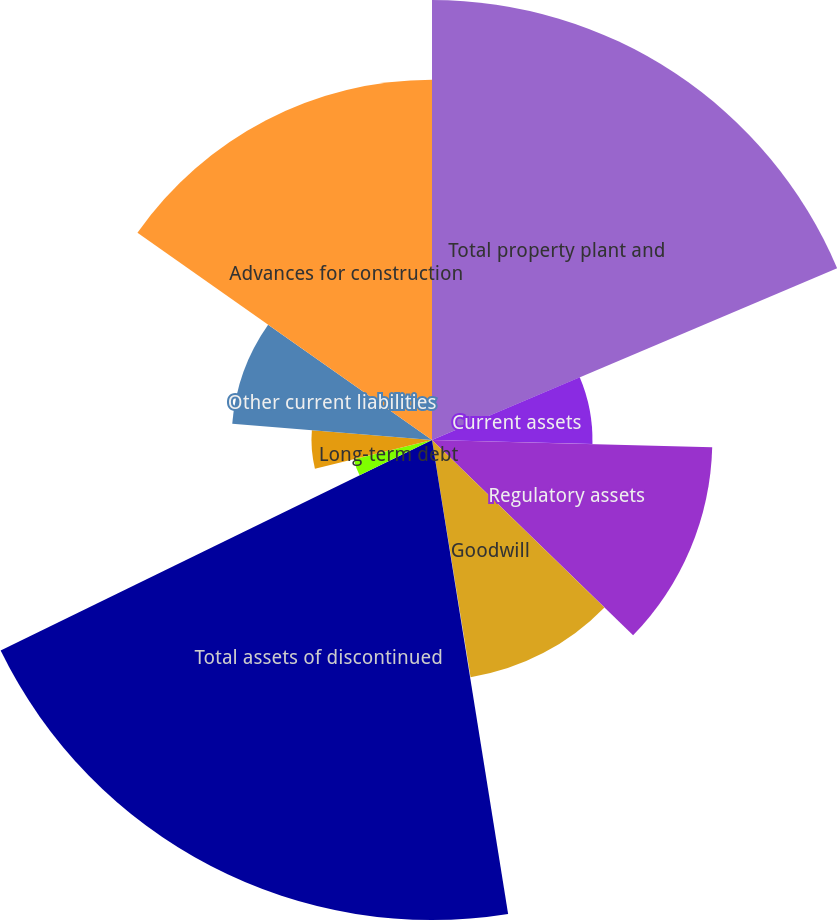Convert chart to OTSL. <chart><loc_0><loc_0><loc_500><loc_500><pie_chart><fcel>Total property plant and<fcel>Current assets<fcel>Regulatory assets<fcel>Goodwill<fcel>Other<fcel>Total assets of discontinued<fcel>Long-term debt<fcel>Current portion of long-term<fcel>Other current liabilities<fcel>Advances for construction<nl><fcel>18.62%<fcel>6.79%<fcel>11.86%<fcel>10.17%<fcel>0.03%<fcel>20.31%<fcel>3.41%<fcel>5.1%<fcel>8.48%<fcel>15.24%<nl></chart> 